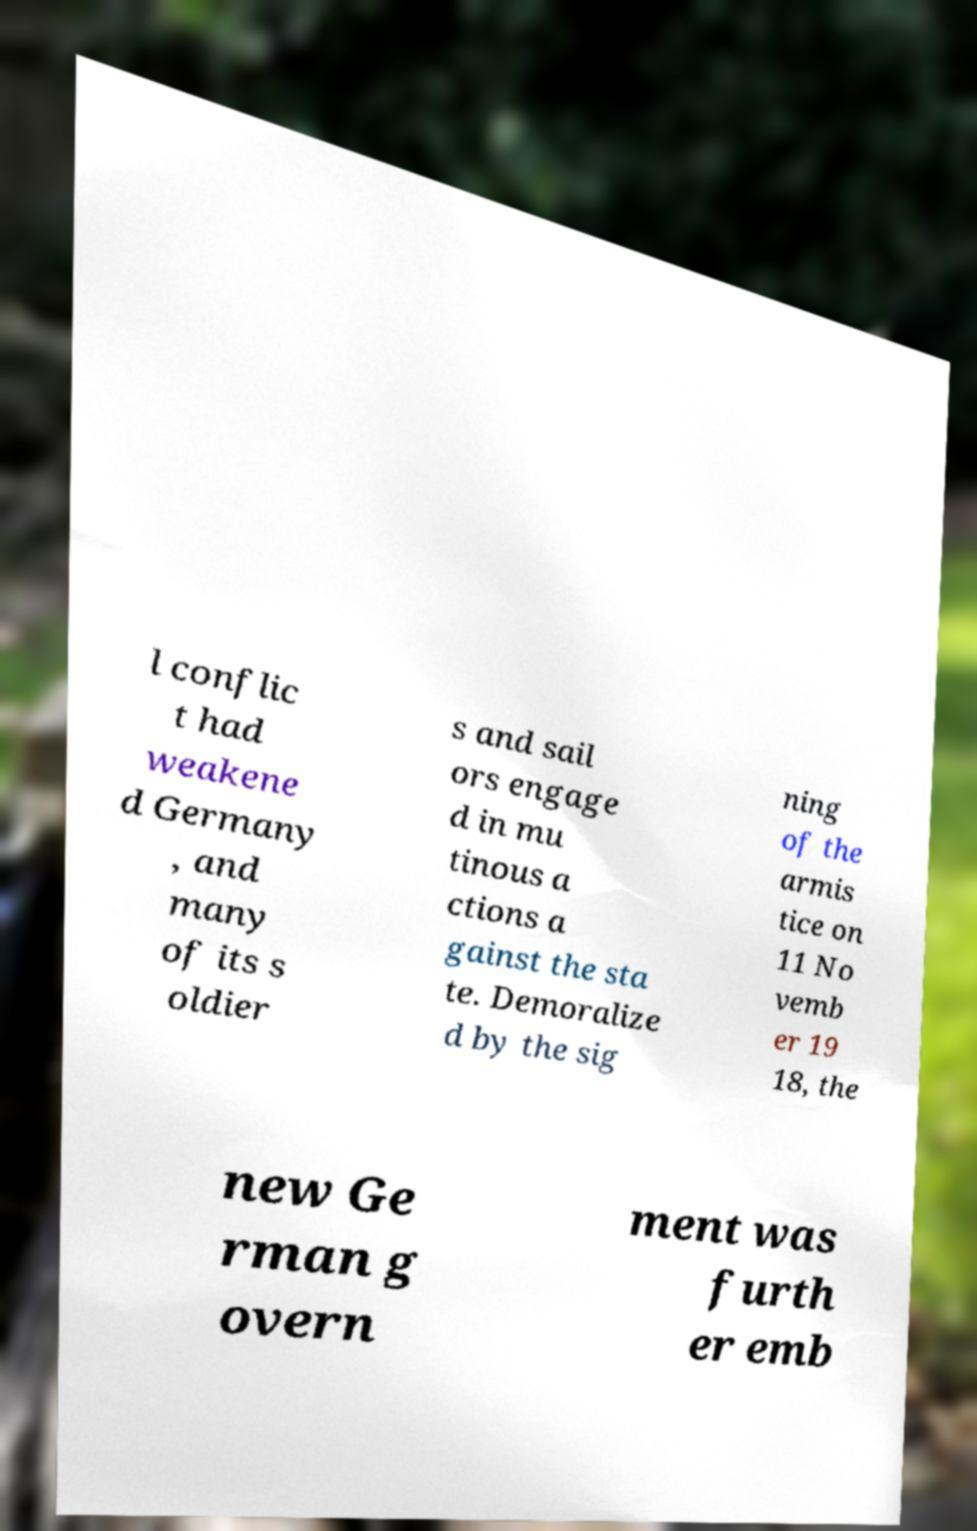Can you read and provide the text displayed in the image?This photo seems to have some interesting text. Can you extract and type it out for me? l conflic t had weakene d Germany , and many of its s oldier s and sail ors engage d in mu tinous a ctions a gainst the sta te. Demoralize d by the sig ning of the armis tice on 11 No vemb er 19 18, the new Ge rman g overn ment was furth er emb 